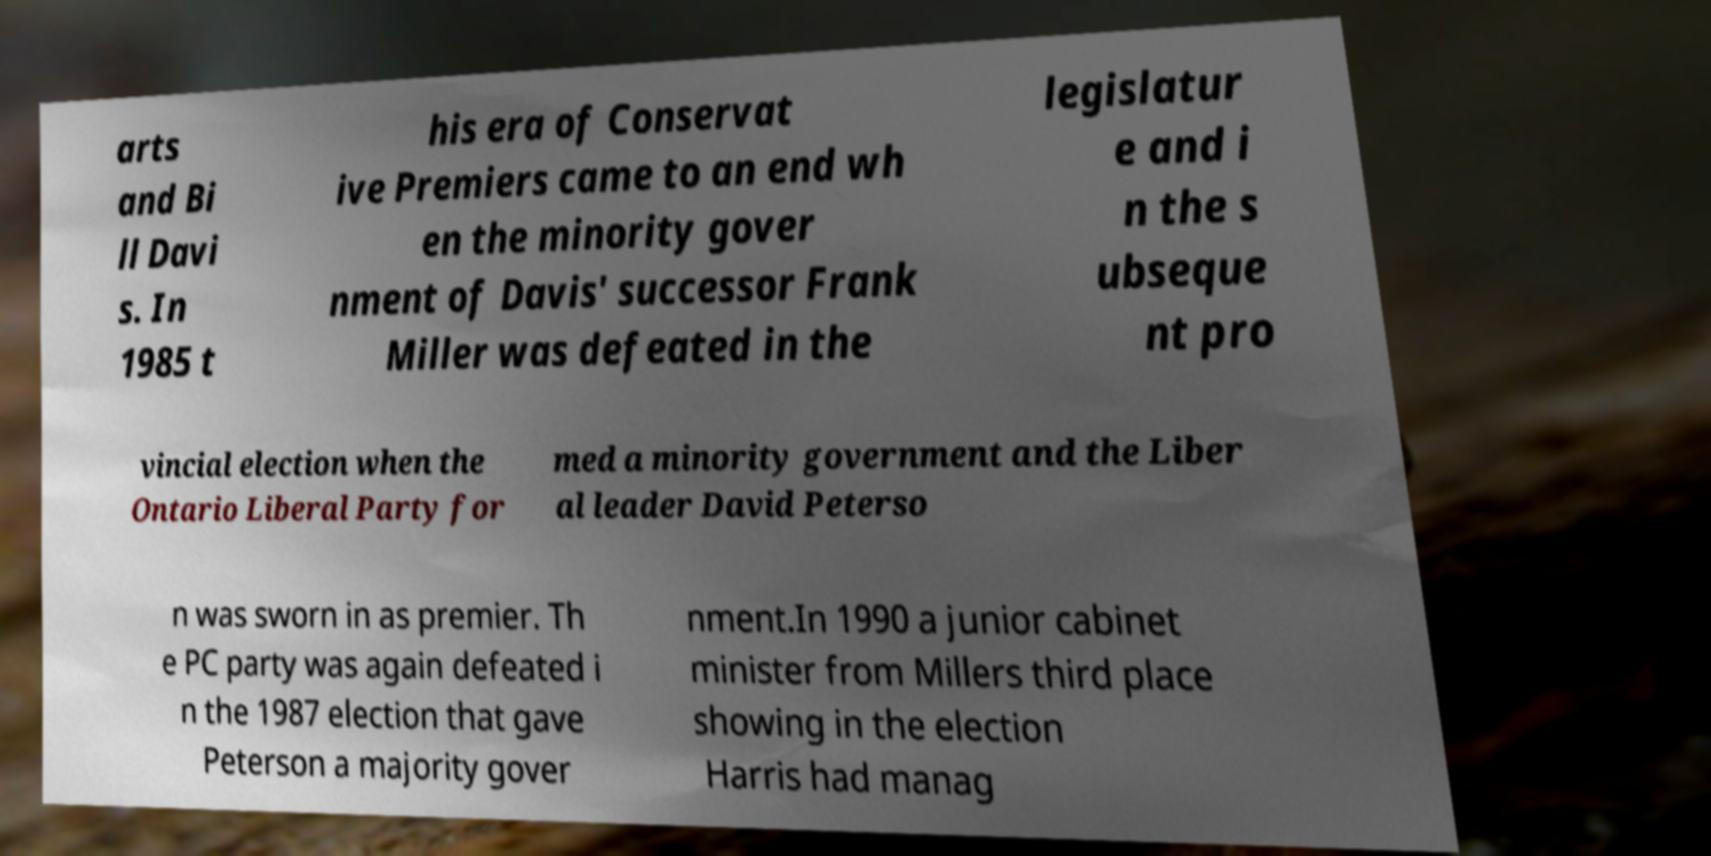Can you accurately transcribe the text from the provided image for me? arts and Bi ll Davi s. In 1985 t his era of Conservat ive Premiers came to an end wh en the minority gover nment of Davis' successor Frank Miller was defeated in the legislatur e and i n the s ubseque nt pro vincial election when the Ontario Liberal Party for med a minority government and the Liber al leader David Peterso n was sworn in as premier. Th e PC party was again defeated i n the 1987 election that gave Peterson a majority gover nment.In 1990 a junior cabinet minister from Millers third place showing in the election Harris had manag 